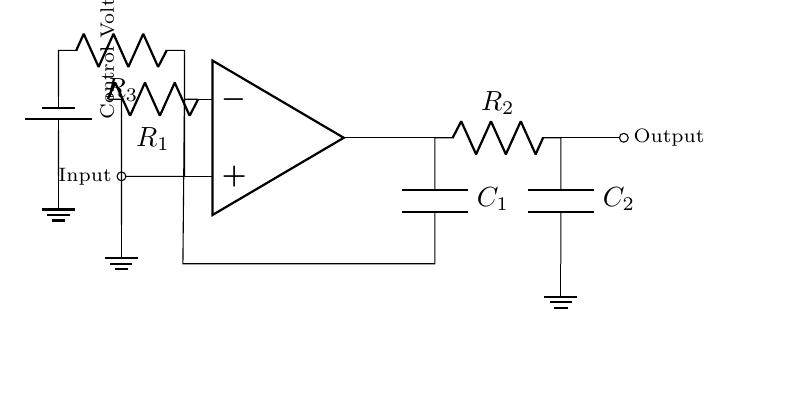What is the function of the op amp in this circuit? The op amp acts as a comparator and amplifies the feedback signal to create oscillation in the circuit.
Answer: Comparator What roles do R1 and C1 play in this oscillator? R1 and C1 form an RC feedback network that determines the frequency of oscillation; R1 influences the charge time of C1.
Answer: Frequency determination What is the purpose of the control voltage in this circuit? The control voltage adjusts the input to the op amp, allowing the oscillator frequency to change, effectively controlling the engine rev limiter.
Answer: Frequency adjustment How many capacitors are present in this circuit? There are two capacitors labeled C1 and C2.
Answer: Two What happens to the output signal if the control voltage increases? An increase in control voltage raises the oscillation frequency, causing the output signal's frequency to increase, effectively raising the rev limiter threshold.
Answer: Increases frequency Which component provides the input to the op amp? The input is provided through a resistor connected to the "+" terminal of the op amp.
Answer: Resistor 